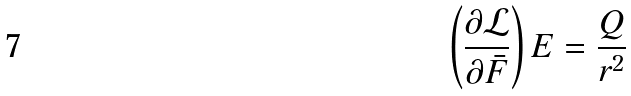<formula> <loc_0><loc_0><loc_500><loc_500>\left ( \frac { \partial \mathcal { L } } { \partial \bar { F } } \right ) E = \frac { Q } { r ^ { 2 } }</formula> 